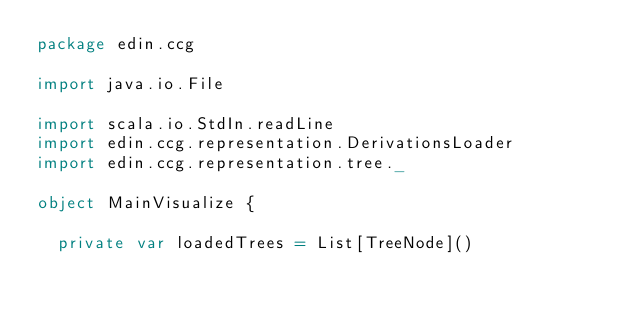<code> <loc_0><loc_0><loc_500><loc_500><_Scala_>package edin.ccg

import java.io.File

import scala.io.StdIn.readLine
import edin.ccg.representation.DerivationsLoader
import edin.ccg.representation.tree._

object MainVisualize {

  private var loadedTrees = List[TreeNode]()
</code> 